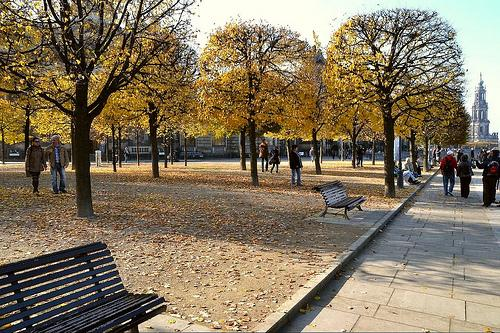Write a concise description of the key elements in this picture. A park with tall trees, benches, and people walking on the sidewalk; leaves on the ground, buildings in the distance, and a bright sky overhead. List the primary subjects and their most distinctive features in this image. Park with tall trees with yellow leaves, black park bench, couple walking together, stone path, fall-colored leaves on ground, white building in distance. Briefly mention the overall atmosphere and the main objects present in the image. A serene autumn park with tall trees, colorful leaves on the ground, benches for resting, and people enjoying a leisurely walk. In a single sentence, describe the main objects and the surrounding area of the picture. A beautiful park during fall, featuring a black bench, yellow and brown leaves, two walking people, and a tall white building in the background. Narrate a brief and simple story based on the key elements you can observe in the image. On a sunny autumn day, a couple strolls through a park filled with yellow leaves, stopping to rest on a black bench, as others walk on the nearby sidewalk. State the overall theme or mood of the image and briefly describe the key elements that contribute to it. The image conveys a peaceful autumn atmosphere, contributed by the tall trees with golden leaves, a black park bench, and people enjoying a stroll in the park. Describe the main components and characteristics of the setting depicted in the photo. The photo showcases a park with tall trees, colorful leaves on the ground, people walking, benches, and a tall white building in the distance. Provide a short and engaging description of what is happening in the image. A charming park in fall, with vibrant leaves, inviting benches, and delighted visitors strolling among the picturesque landscape. Give a quick and concise summary of the scene captured in the image. Autumn park scene with fall foliage, benches, people walking, and a glimpse of a white building behind the trees. Identify the primary elements of the image and describe how they are interacting. In an autumn park scene, a couple walks together surrounded by tall trees, people on the sidewalk, and a black bench ready for them to rest upon. 